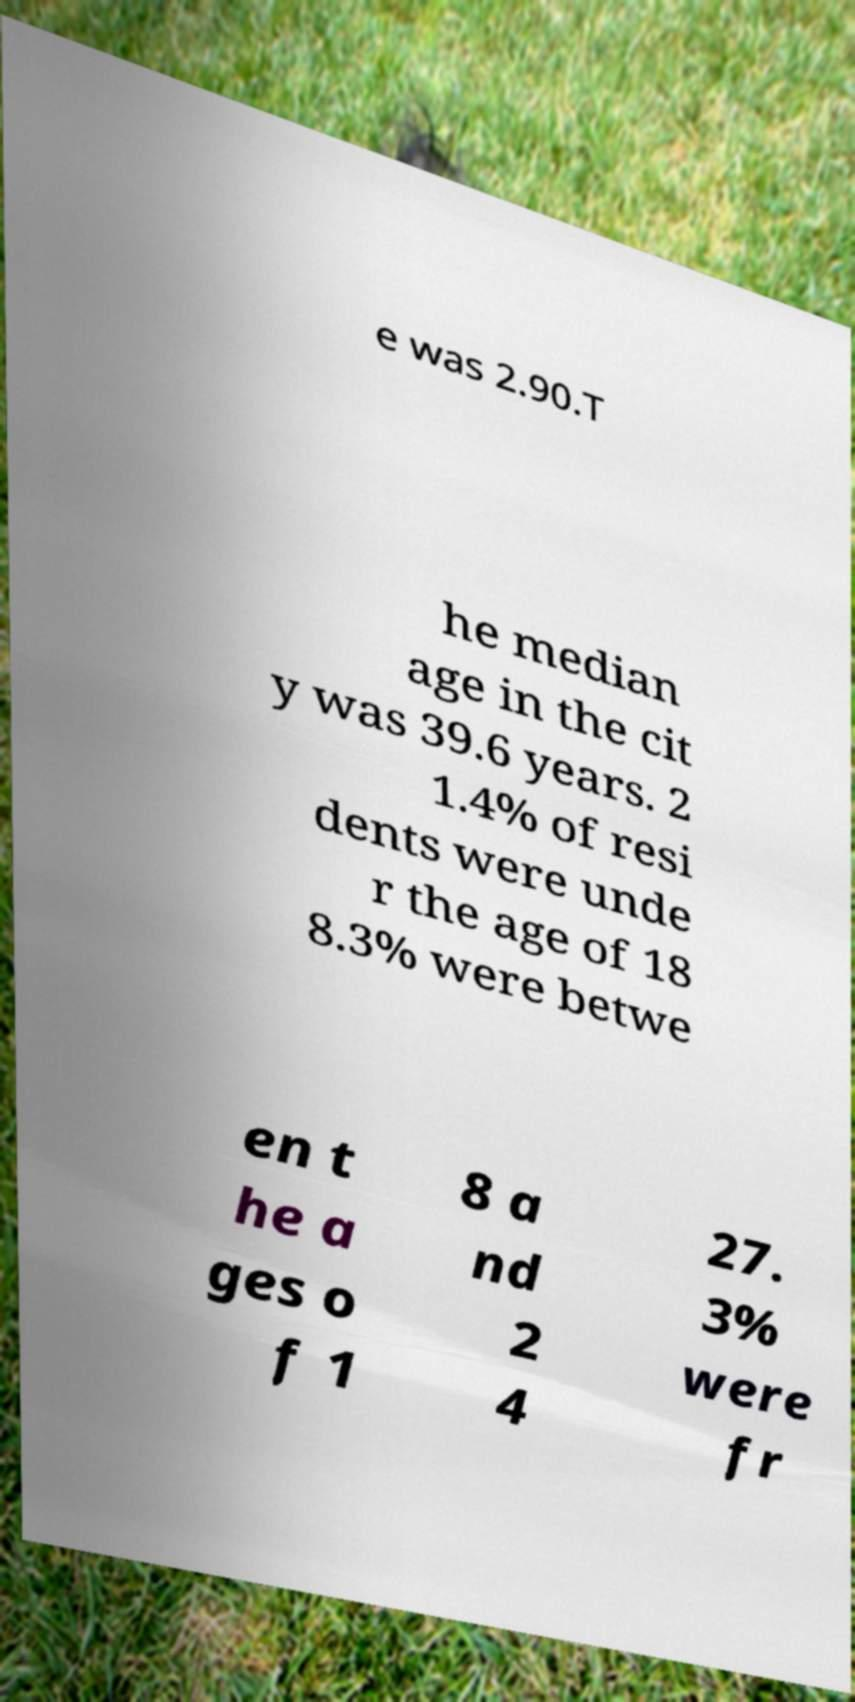I need the written content from this picture converted into text. Can you do that? e was 2.90.T he median age in the cit y was 39.6 years. 2 1.4% of resi dents were unde r the age of 18 8.3% were betwe en t he a ges o f 1 8 a nd 2 4 27. 3% were fr 